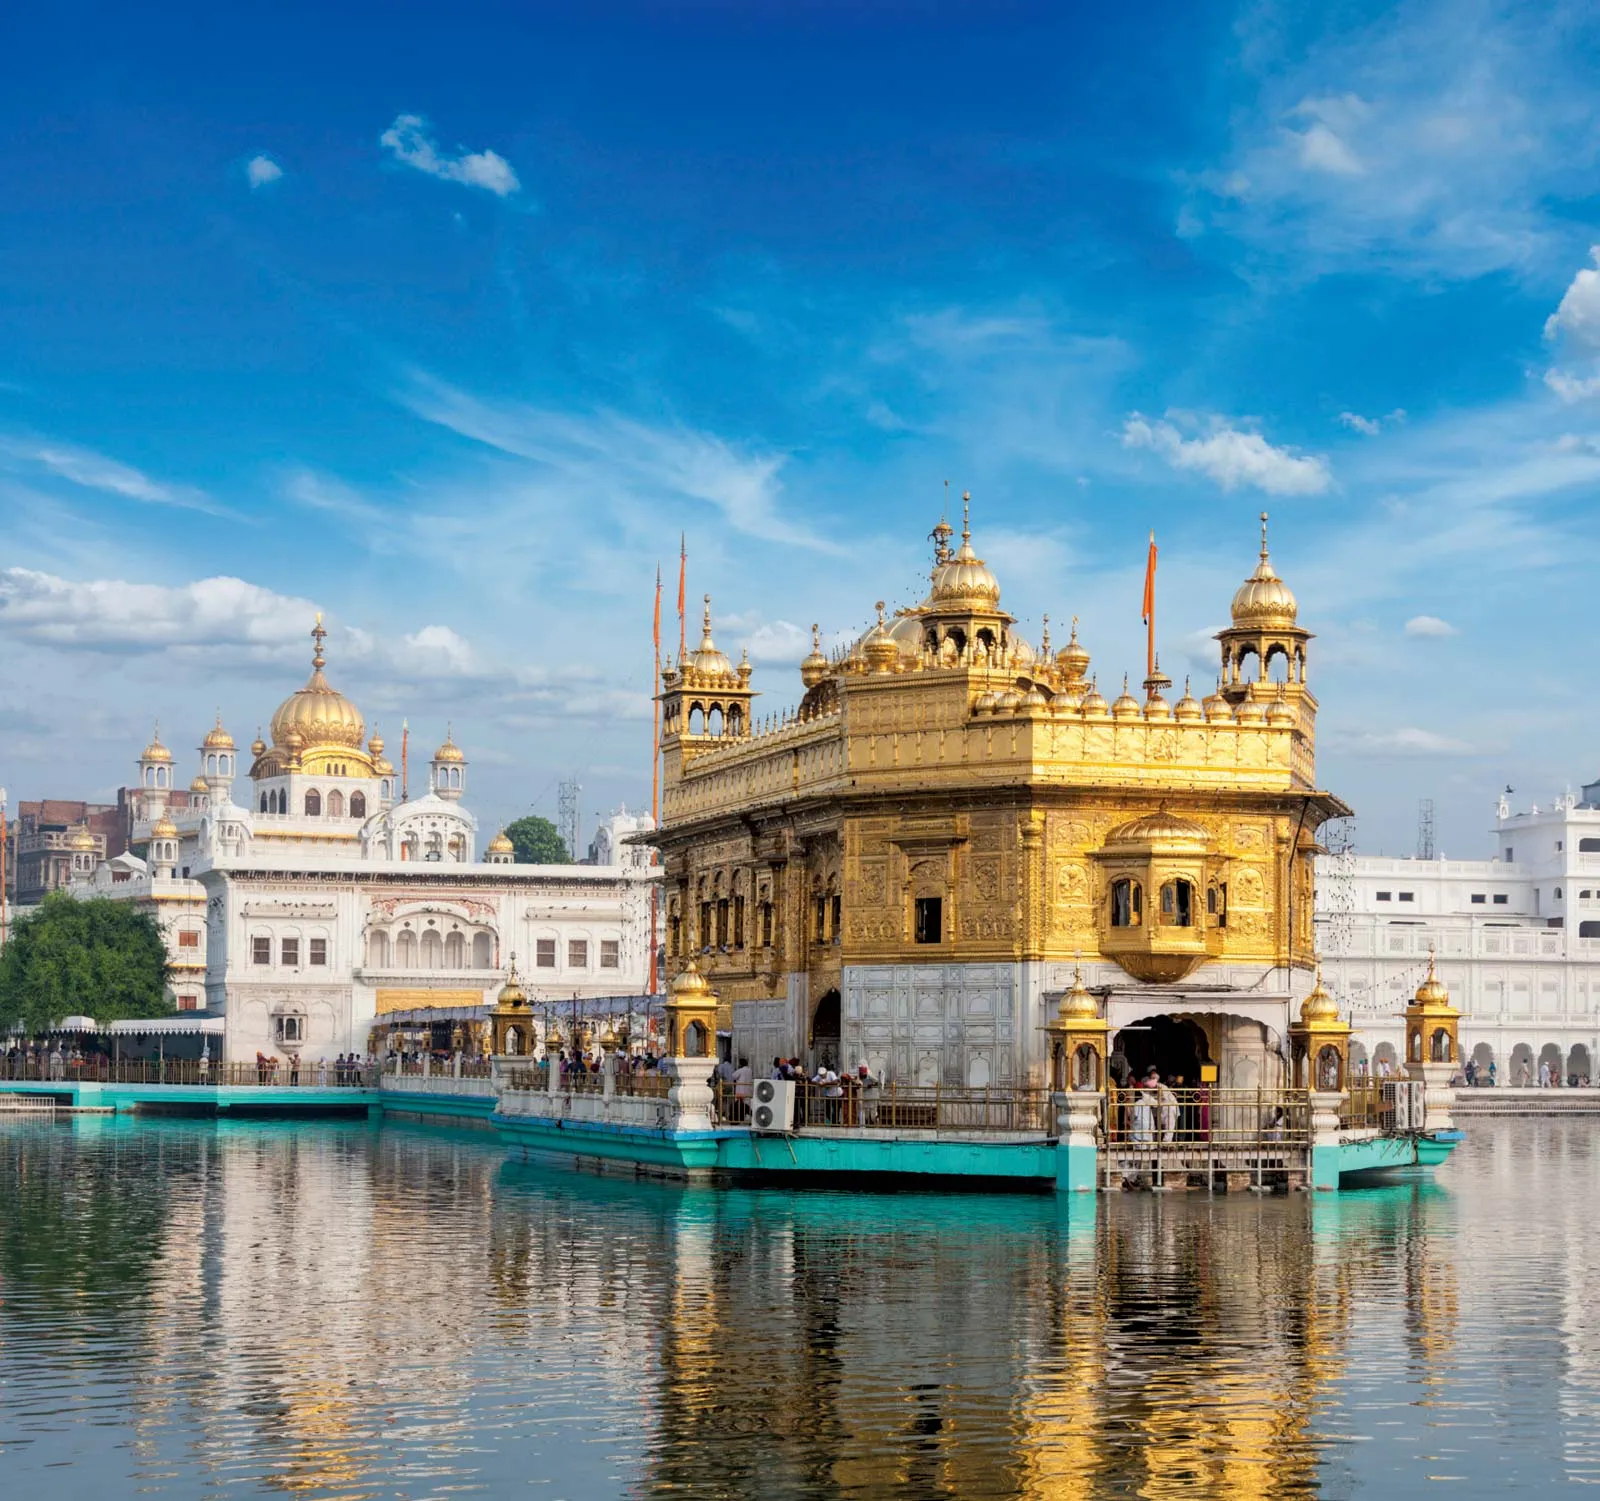Write a detailed description of the given image. The image captures the Golden Temple, an iconic Sikh temple located in the city of Amritsar, India. The temple is renowned for its stunning gold-plated exterior, which glistens under the sunlight and stands in stark contrast to its white marble base. The temple is surrounded by the serene waters of the Amrit Sarovar, a holy pool that reflects the grandeur of the structure, creating a tranquil atmosphere. The sky above is clear with a few scattered clouds, adding to the picturesque beauty of the scene. In the background, other white buildings with golden domes complement the main temple, enhancing the serene and sacred ambiance of the area. The perspective of the photograph provides a comprehensive view of the surroundings, encapsulating the essence and tranquility of this revered landmark. 